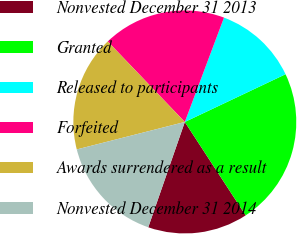<chart> <loc_0><loc_0><loc_500><loc_500><pie_chart><fcel>Nonvested December 31 2013<fcel>Granted<fcel>Released to participants<fcel>Forfeited<fcel>Awards surrendered as a result<fcel>Nonvested December 31 2014<nl><fcel>14.51%<fcel>22.85%<fcel>12.24%<fcel>17.87%<fcel>16.81%<fcel>15.72%<nl></chart> 